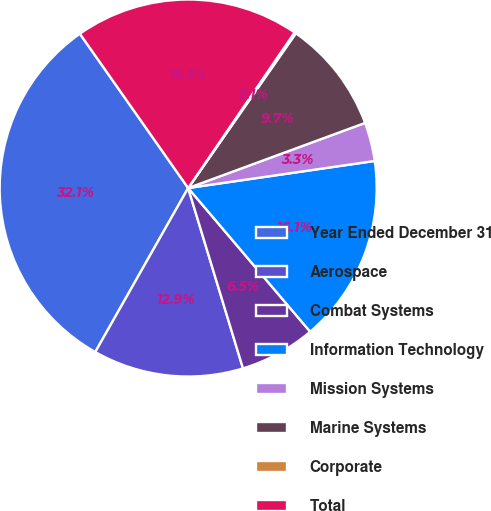<chart> <loc_0><loc_0><loc_500><loc_500><pie_chart><fcel>Year Ended December 31<fcel>Aerospace<fcel>Combat Systems<fcel>Information Technology<fcel>Mission Systems<fcel>Marine Systems<fcel>Corporate<fcel>Total<nl><fcel>32.06%<fcel>12.9%<fcel>6.51%<fcel>16.09%<fcel>3.32%<fcel>9.71%<fcel>0.13%<fcel>19.29%<nl></chart> 